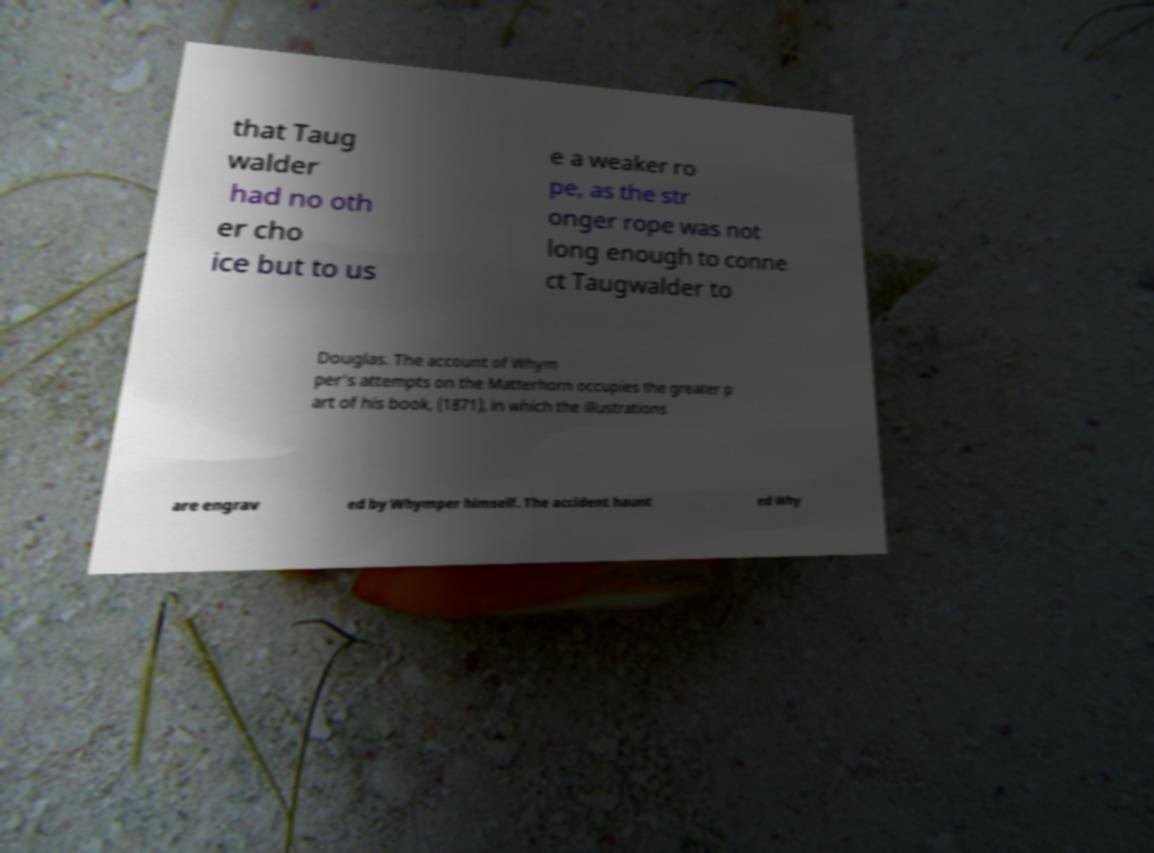Please identify and transcribe the text found in this image. that Taug walder had no oth er cho ice but to us e a weaker ro pe, as the str onger rope was not long enough to conne ct Taugwalder to Douglas. The account of Whym per's attempts on the Matterhorn occupies the greater p art of his book, (1871), in which the illustrations are engrav ed by Whymper himself. The accident haunt ed Why 